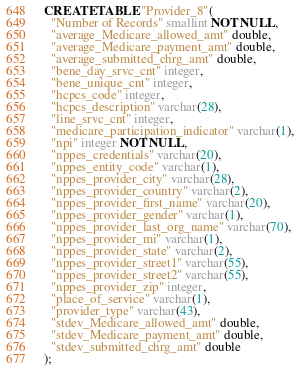Convert code to text. <code><loc_0><loc_0><loc_500><loc_500><_SQL_>CREATE TABLE "Provider_8"(
  "Number of Records" smallint NOT NULL,
  "average_Medicare_allowed_amt" double,
  "average_Medicare_payment_amt" double,
  "average_submitted_chrg_amt" double,
  "bene_day_srvc_cnt" integer,
  "bene_unique_cnt" integer,
  "hcpcs_code" integer,
  "hcpcs_description" varchar(28),
  "line_srvc_cnt" integer,
  "medicare_participation_indicator" varchar(1),
  "npi" integer NOT NULL,
  "nppes_credentials" varchar(20),
  "nppes_entity_code" varchar(1),
  "nppes_provider_city" varchar(28),
  "nppes_provider_country" varchar(2),
  "nppes_provider_first_name" varchar(20),
  "nppes_provider_gender" varchar(1),
  "nppes_provider_last_org_name" varchar(70),
  "nppes_provider_mi" varchar(1),
  "nppes_provider_state" varchar(2),
  "nppes_provider_street1" varchar(55),
  "nppes_provider_street2" varchar(55),
  "nppes_provider_zip" integer,
  "place_of_service" varchar(1),
  "provider_type" varchar(43),
  "stdev_Medicare_allowed_amt" double,
  "stdev_Medicare_payment_amt" double,
  "stdev_submitted_chrg_amt" double
);
</code> 